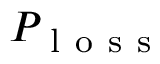<formula> <loc_0><loc_0><loc_500><loc_500>P _ { l o s s }</formula> 